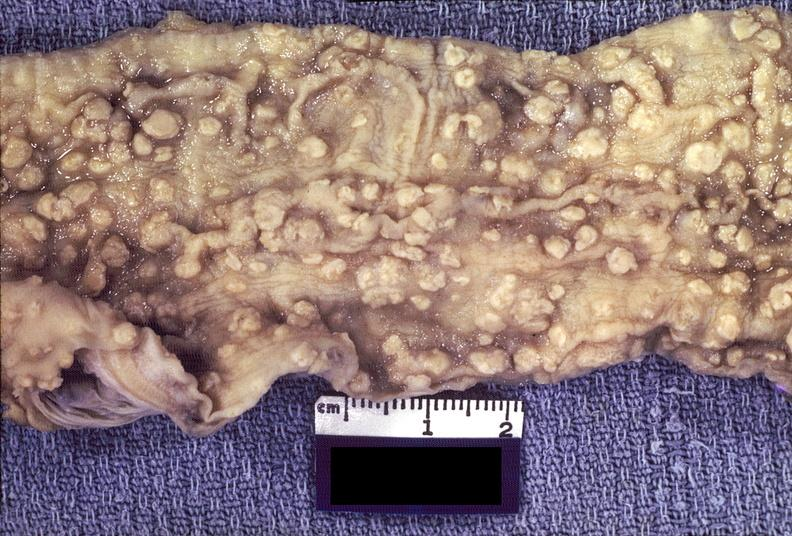does close-up of lesion show colon, amebic colitis?
Answer the question using a single word or phrase. No 